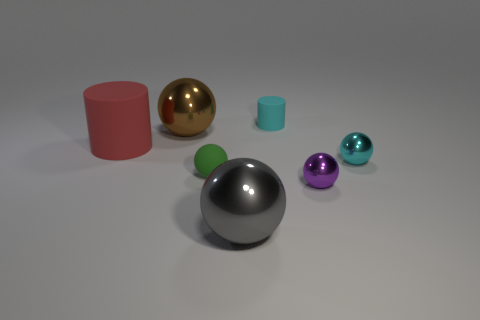Subtract all blue balls. Subtract all blue cubes. How many balls are left? 5 Add 1 brown shiny objects. How many objects exist? 8 Subtract all cylinders. How many objects are left? 5 Add 4 big red things. How many big red things are left? 5 Add 5 big red cylinders. How many big red cylinders exist? 6 Subtract 1 brown spheres. How many objects are left? 6 Subtract all cyan rubber cylinders. Subtract all big red matte cylinders. How many objects are left? 5 